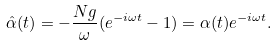Convert formula to latex. <formula><loc_0><loc_0><loc_500><loc_500>\hat { \alpha } ( t ) = - \frac { N g } { \omega } ( e ^ { - i \omega t } - 1 ) = \alpha ( t ) e ^ { - i \omega t } .</formula> 